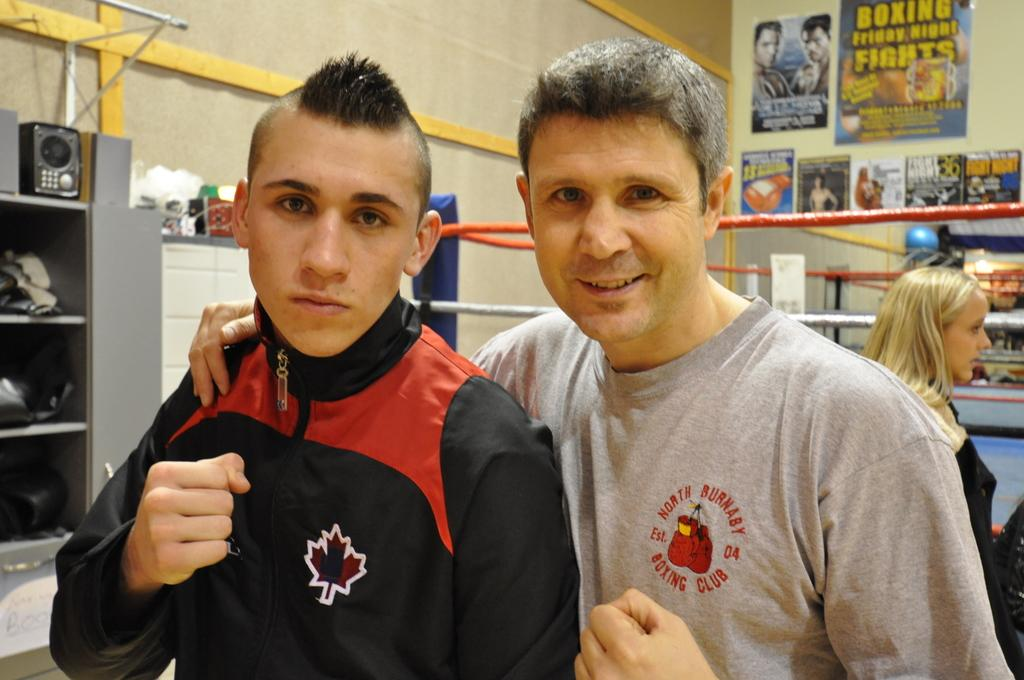<image>
Present a compact description of the photo's key features. A man wearing a North Burnaby boxing club t shirt. 